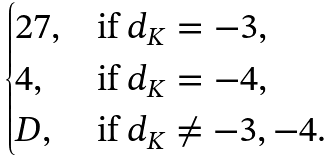Convert formula to latex. <formula><loc_0><loc_0><loc_500><loc_500>\begin{cases} 2 7 , & \text {if $d_{K}=-3$,} \\ 4 , & \text {if $d_{K}=-4$,} \\ D , & \text {if $d_{K}\neq -3,-4$} . \end{cases}</formula> 